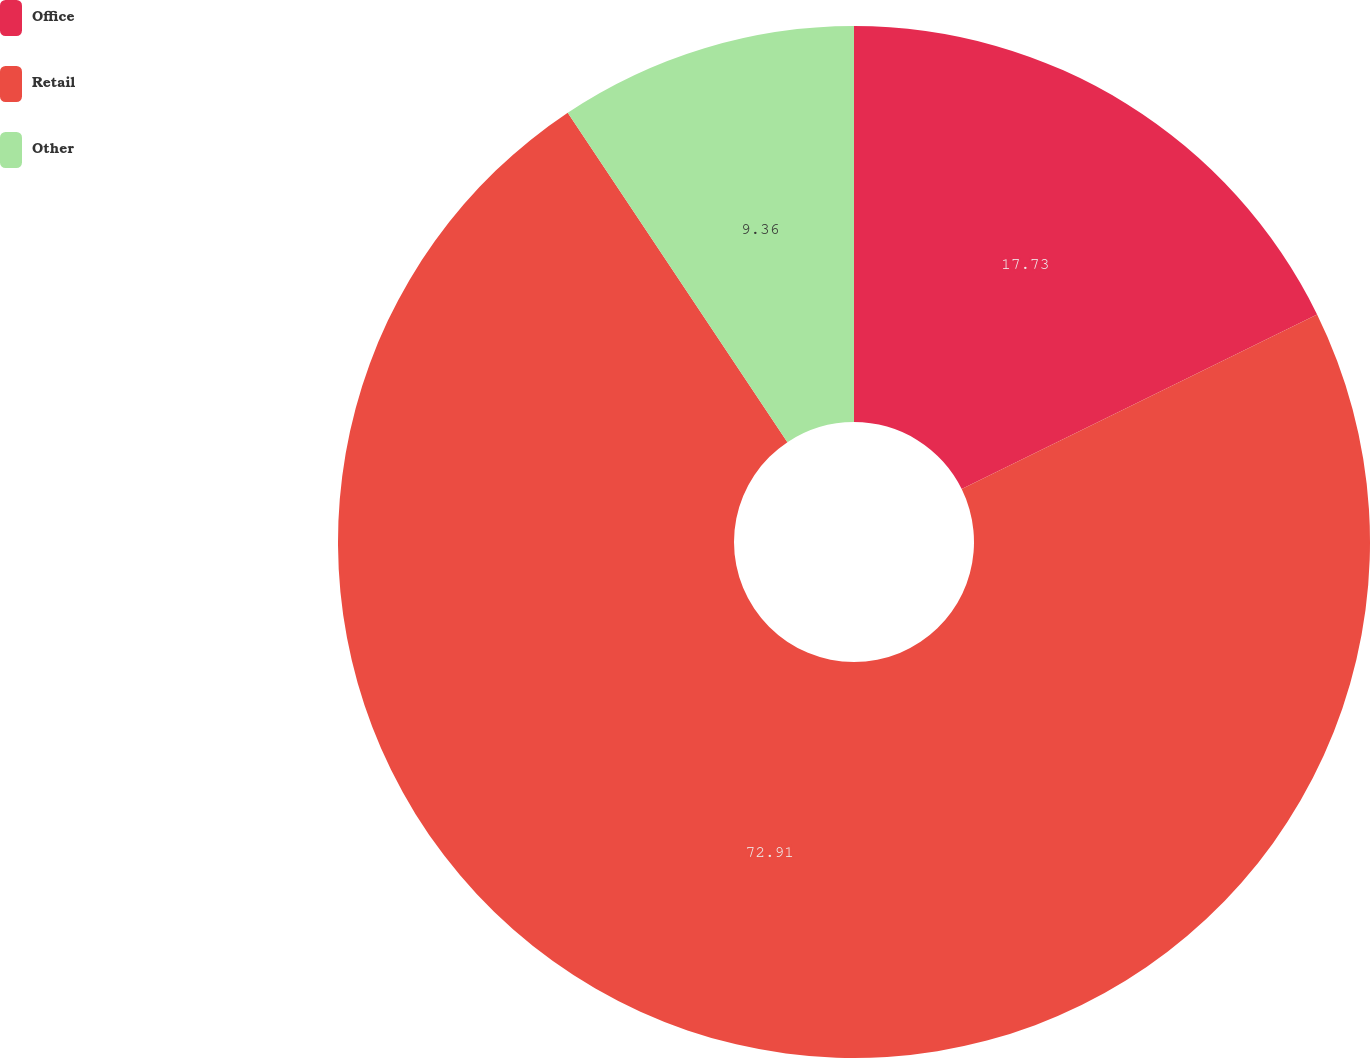Convert chart. <chart><loc_0><loc_0><loc_500><loc_500><pie_chart><fcel>Office<fcel>Retail<fcel>Other<nl><fcel>17.73%<fcel>72.91%<fcel>9.36%<nl></chart> 